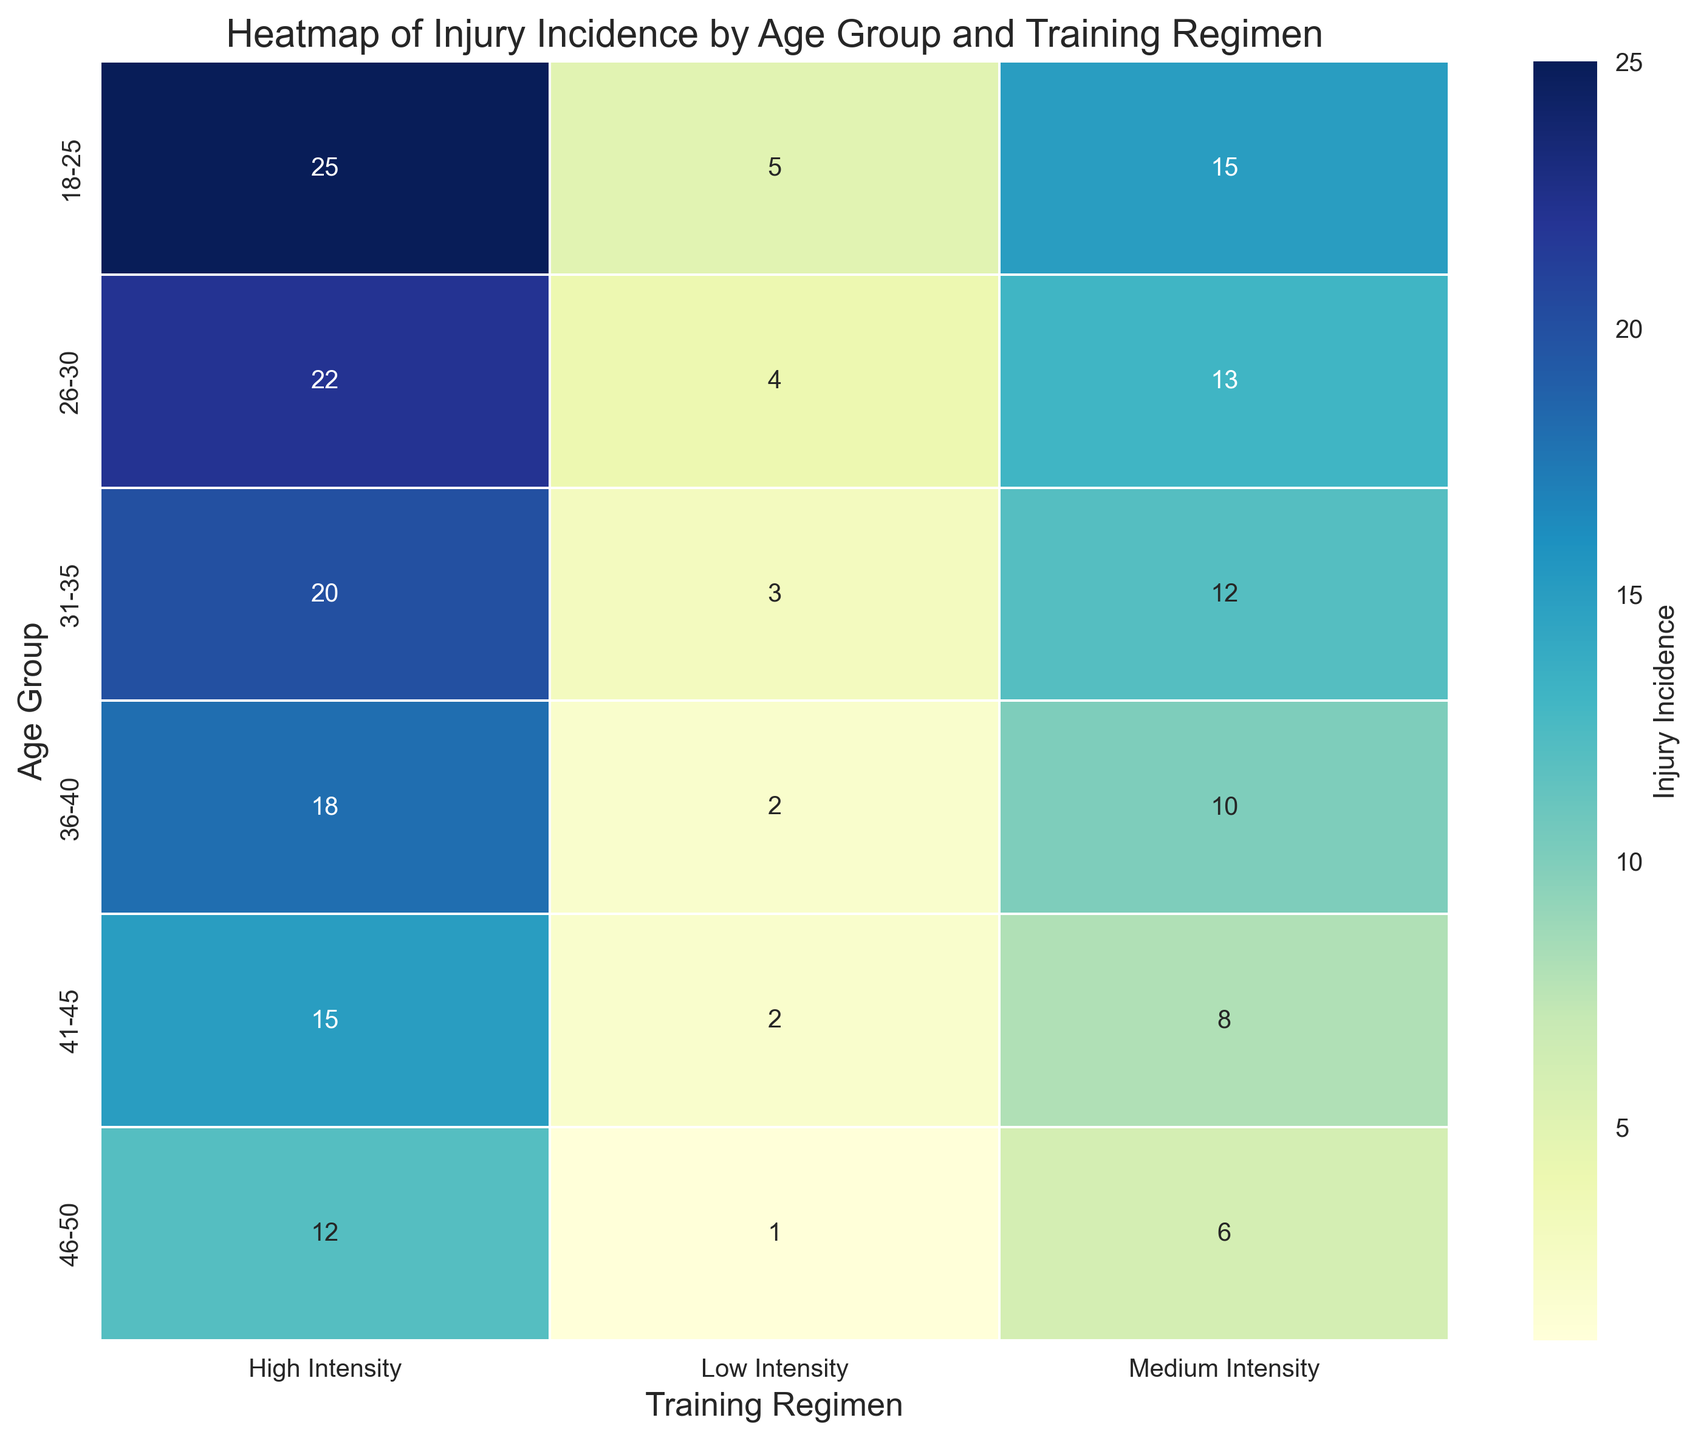How does the injury incidence change with increasing training intensity for the age group 26-30? To determine how injury incidence changes with increasing training intensity for the age group 26-30, observe the values in the row for "26-30" across the columns "Low Intensity," "Medium Intensity," and "High Intensity." The injury incidences are 4, 13, and 22, respectively, indicating an increasing trend.
Answer: It increases Which age group has the highest difference in injury incidence between low and high intensity training? To find the age group with the highest difference, calculate the difference in injury incidence for all age groups between "Low Intensity" and "High Intensity" columns. The differences are: 18-25: 20, 26-30: 18, 31-35: 17, 36-40: 16, 41-45: 13, 46-50: 11. The age group 18-25 has the highest difference (25 - 5 = 20).
Answer: 18-25 What is the total injury incidence for the age group 36-40 across all training regimens? To find the total injury incidence for the age group 36-40, sum up the values in the row for "36-40." The injury incidences are 2 (Low Intensity), 10 (Medium Intensity), and 18 (High Intensity). The total is 2 + 10 + 18 = 30.
Answer: 30 Compare the medium intensity training regimen in terms of injury incidence between age groups 18-25 and 41-45. Compare the values in the column "Medium Intensity" for age groups "18-25" and "41-45." The values are 15 for "18-25" and 8 for "41-45." The age group "18-25" has a higher injury incidence.
Answer: 18-25 has higher injury incidence Which training regimen and age group combination has the lowest injury incidence? Examine the heatmap to find the cell with the lowest value. The combination with the lowest injury incidence is in the "46-50" age group with the "Low Intensity" training regimen, which has a value of 1.
Answer: 46-50, Low Intensity Is the trend of injury incidence consistent across all age groups when moving from low to high intensity training? Check the values in each row from "Low Intensity" to "High Intensity." For each age group, the injury incidence increases as the training intensity increases. E.g., for "18-25," it is 5, 15, 25; for "26-30," it is 4, 13, 22; and similarly for other age groups.
Answer: Yes What is the average injury incidence for high-intensity training across all age groups? To find the average injury incidence for high-intensity training, sum the values in the "High Intensity" column and divide by the number of age groups. The values are 25, 22, 20, 18, 15, 12. The sum is 112, and there are 6 age groups, so the average is 112 / 6 ≈ 18.67.
Answer: Approximately 18.67 Describe the visual difference in injury incidence between low and high intensity training regimens using color intensity for the age group 31-35. Observe the color intensity in the heatmap for the values 3 (Low Intensity) and 20 (High Intensity) in the row corresponding to "31-35." The cell for 3 will be much lighter in shade compared to the cell for 20, indicating a visually lower injury incidence for low intensity training.
Answer: High intensity appears much darker 